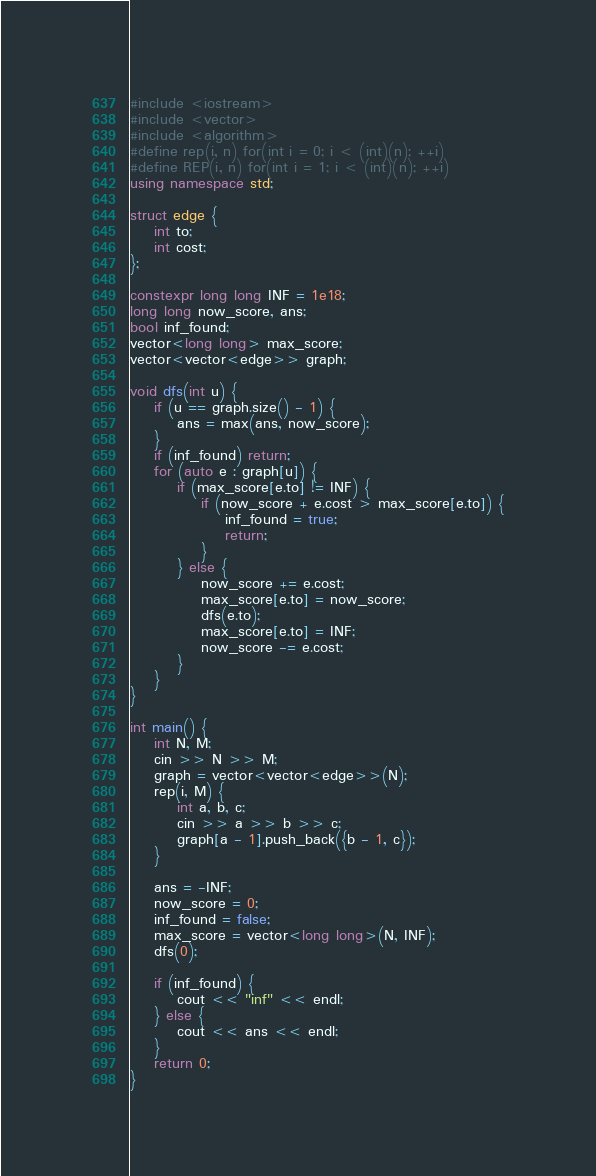Convert code to text. <code><loc_0><loc_0><loc_500><loc_500><_C++_>#include <iostream>
#include <vector>
#include <algorithm>
#define rep(i, n) for(int i = 0; i < (int)(n); ++i)
#define REP(i, n) for(int i = 1; i < (int)(n); ++i)
using namespace std;

struct edge {
    int to;
    int cost;
};

constexpr long long INF = 1e18;
long long now_score, ans;
bool inf_found;
vector<long long> max_score;
vector<vector<edge>> graph;

void dfs(int u) {
    if (u == graph.size() - 1) {
        ans = max(ans, now_score);
    }
    if (inf_found) return;
    for (auto e : graph[u]) {
        if (max_score[e.to] != INF) {
            if (now_score + e.cost > max_score[e.to]) {
                inf_found = true;
                return;
            }
        } else {
            now_score += e.cost;
            max_score[e.to] = now_score;
            dfs(e.to);
            max_score[e.to] = INF;
            now_score -= e.cost;
        }
    }
}

int main() {
    int N, M;
    cin >> N >> M;
    graph = vector<vector<edge>>(N);
    rep(i, M) {
        int a, b, c;
        cin >> a >> b >> c;
        graph[a - 1].push_back({b - 1, c});
    }
    
    ans = -INF;
    now_score = 0;
    inf_found = false;
    max_score = vector<long long>(N, INF);
    dfs(0);
    
    if (inf_found) {
        cout << "inf" << endl;
    } else {
        cout << ans << endl;
    }
    return 0;
}
</code> 